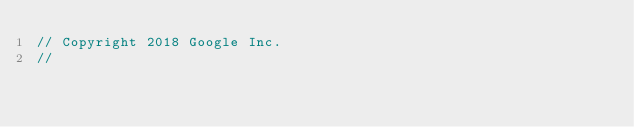Convert code to text. <code><loc_0><loc_0><loc_500><loc_500><_Go_>// Copyright 2018 Google Inc.
//</code> 